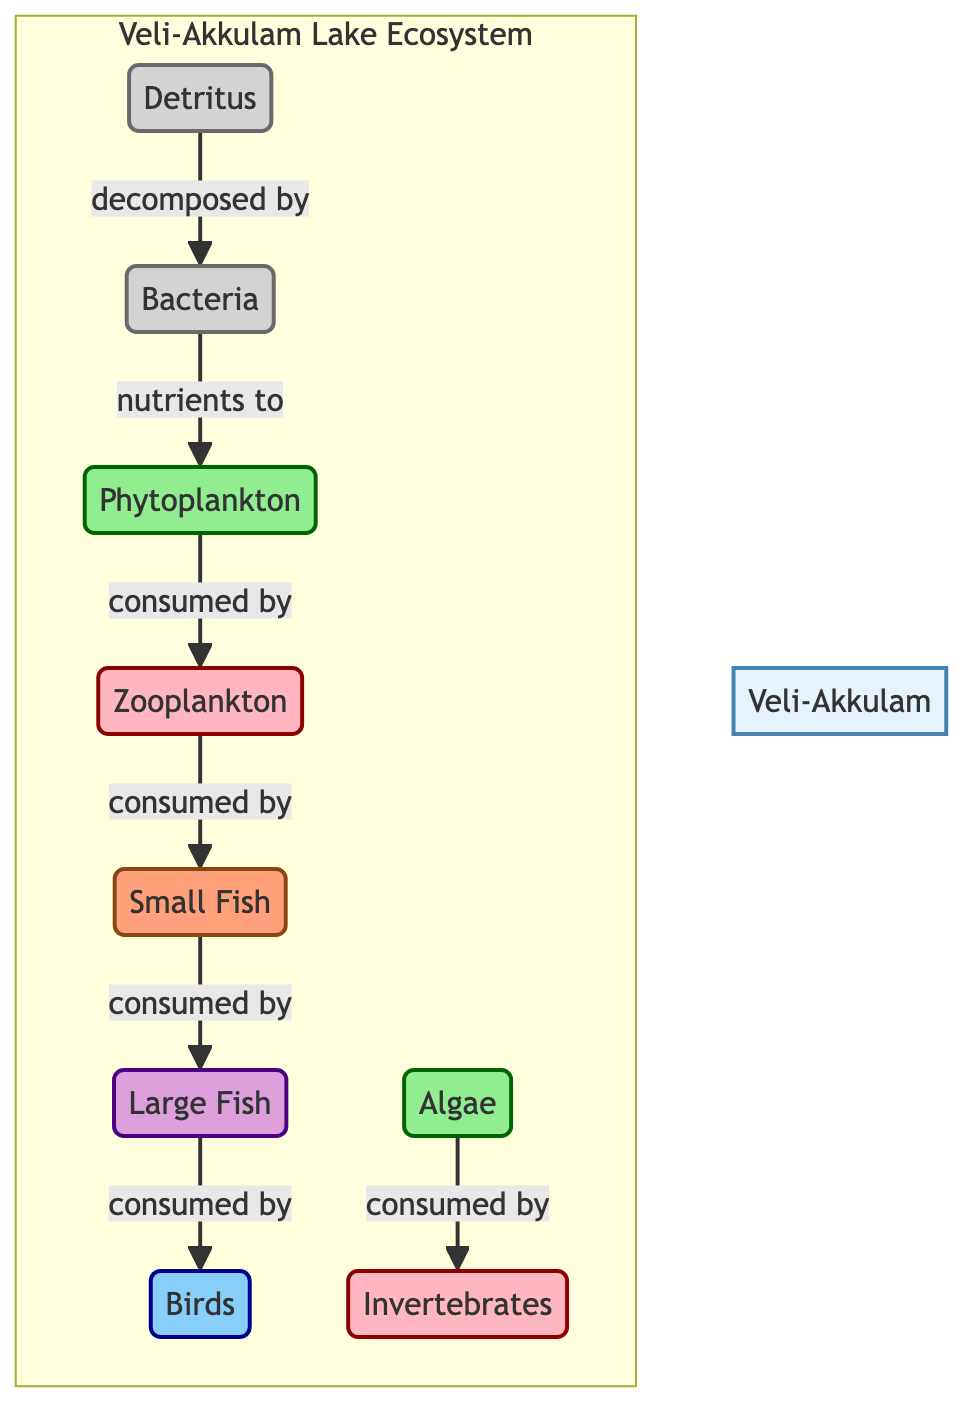What is the first trophic level in the Veli-Akkulam Lake Ecosystem? The first trophic level in the ecosystem is occupied by phytoplankton, which is classified as a producer. This can be determined by locating the producers in the diagram, which are at the base of the trophic levels.
Answer: Phytoplankton How many types of consumers are identified in the diagram? The diagram identifies four types of consumers: zooplankton, small fish, large fish, and birds. Each consumer category can be counted by examining the consumer nodes in the diagram.
Answer: Four Which species are consumed by large fish according to the diagram? The large fish are directly connected to small fish, indicating that they consume small fish. To find the answer, we look for the arrow leading to large fish that shows what directly feeds them.
Answer: Small fish What role do bacteria play in the Veli-Akkulam Lake Ecosystem? Bacteria act as decomposers in this ecosystem. They break down detritus, which can be inferred by observing their connection to the detritus node and understanding their function in nutrient cycling.
Answer: Decomposers How do phytoplankton receive nutrients in this ecosystem? Phytoplankton receive nutrients via bacteria, which decompose detritus and release nutrients back into the ecosystem. This relationship is illustrated by the arrows showing how bacteria provide nutrients to phytoplankton, demonstrating the cycling of materials.
Answer: Bacteria What are the primary producers in this ecosystem? The primary producers identified in the diagram are phytoplankton and algae. This can be determined by identifying the nodes classified under the producer category in the diagram.
Answer: Phytoplankton and algae Which consumer is directly linked to zooplankton? Zooplankton is directly linked to small fish as the next tier in the food web, which indicates that small fish consume zooplankton. This is visible from the arrow pointing from zooplankton to small fish in the diagram.
Answer: Small fish What type of relationship exists between detritus and bacteria? The relationship is one of decomposition, where bacteria decompose detritus in the ecosystem, as indicated by the arrow pointing from detritus to bacteria in the diagram. This reflects the role of bacteria in breaking down organic material.
Answer: Decomposition 